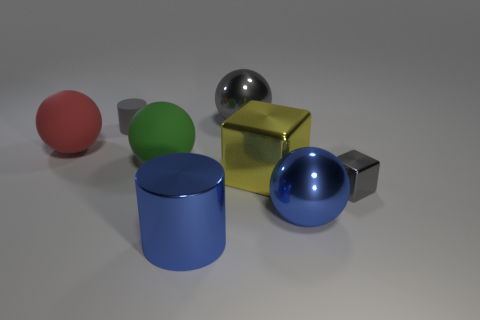Can you describe the lighting and shadows in the scene? The image appears to be evenly lit from above, casting soft, diffuse shadows directly beneath each object. The softness of the shadows suggests a broad light source, reducing harsh contrasts. 